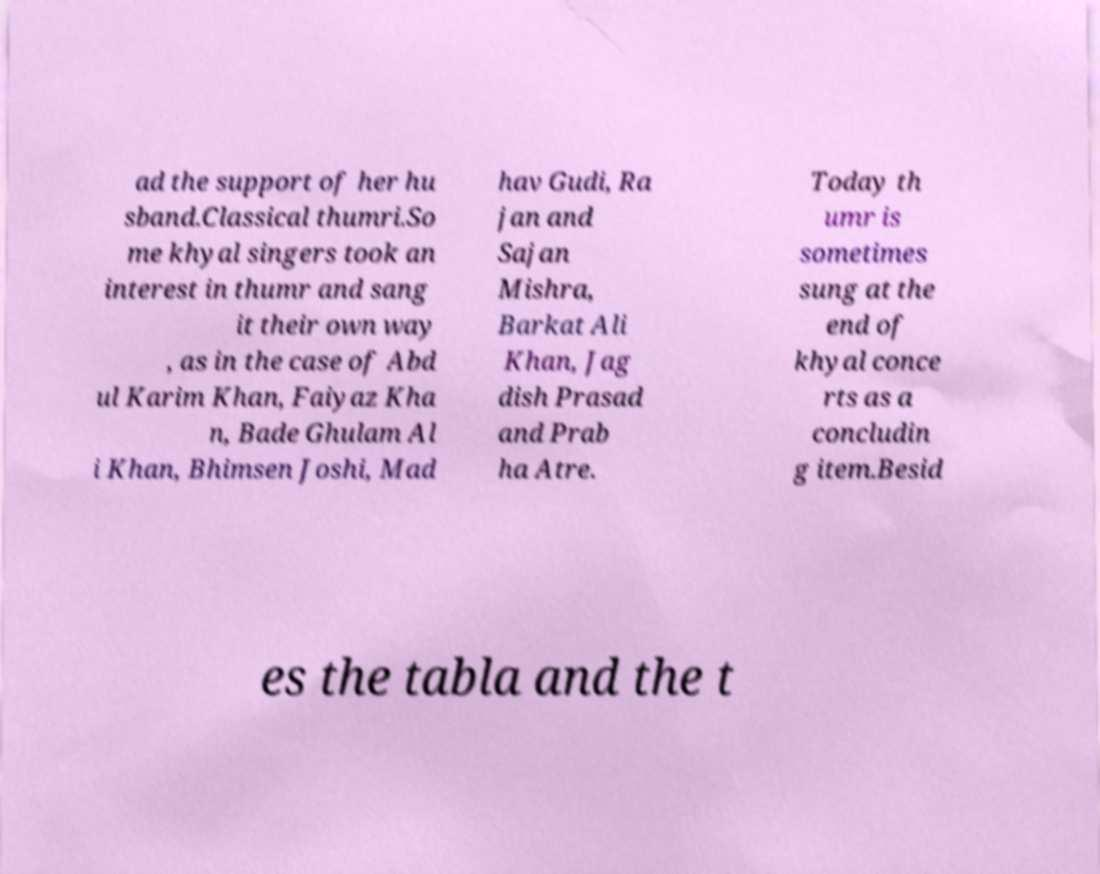I need the written content from this picture converted into text. Can you do that? ad the support of her hu sband.Classical thumri.So me khyal singers took an interest in thumr and sang it their own way , as in the case of Abd ul Karim Khan, Faiyaz Kha n, Bade Ghulam Al i Khan, Bhimsen Joshi, Mad hav Gudi, Ra jan and Sajan Mishra, Barkat Ali Khan, Jag dish Prasad and Prab ha Atre. Today th umr is sometimes sung at the end of khyal conce rts as a concludin g item.Besid es the tabla and the t 